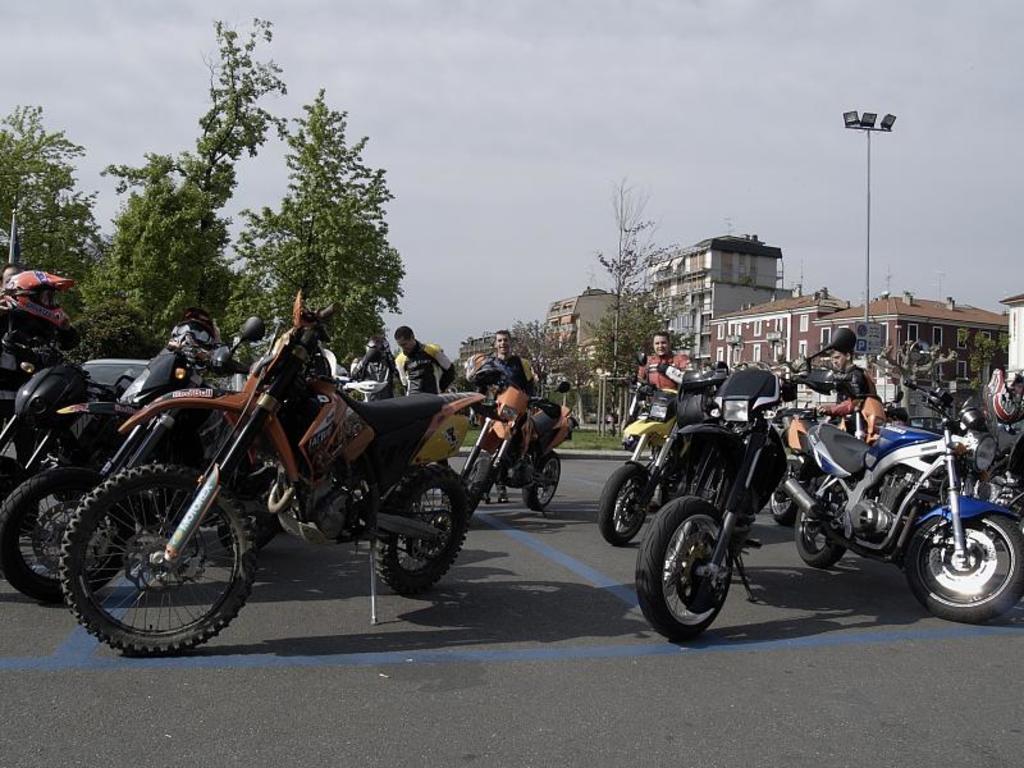Could you give a brief overview of what you see in this image? In this image we can see some vehicles and persons on the road, there are some trees, building with windows and a pole with lights, in the background we can see the sky. 